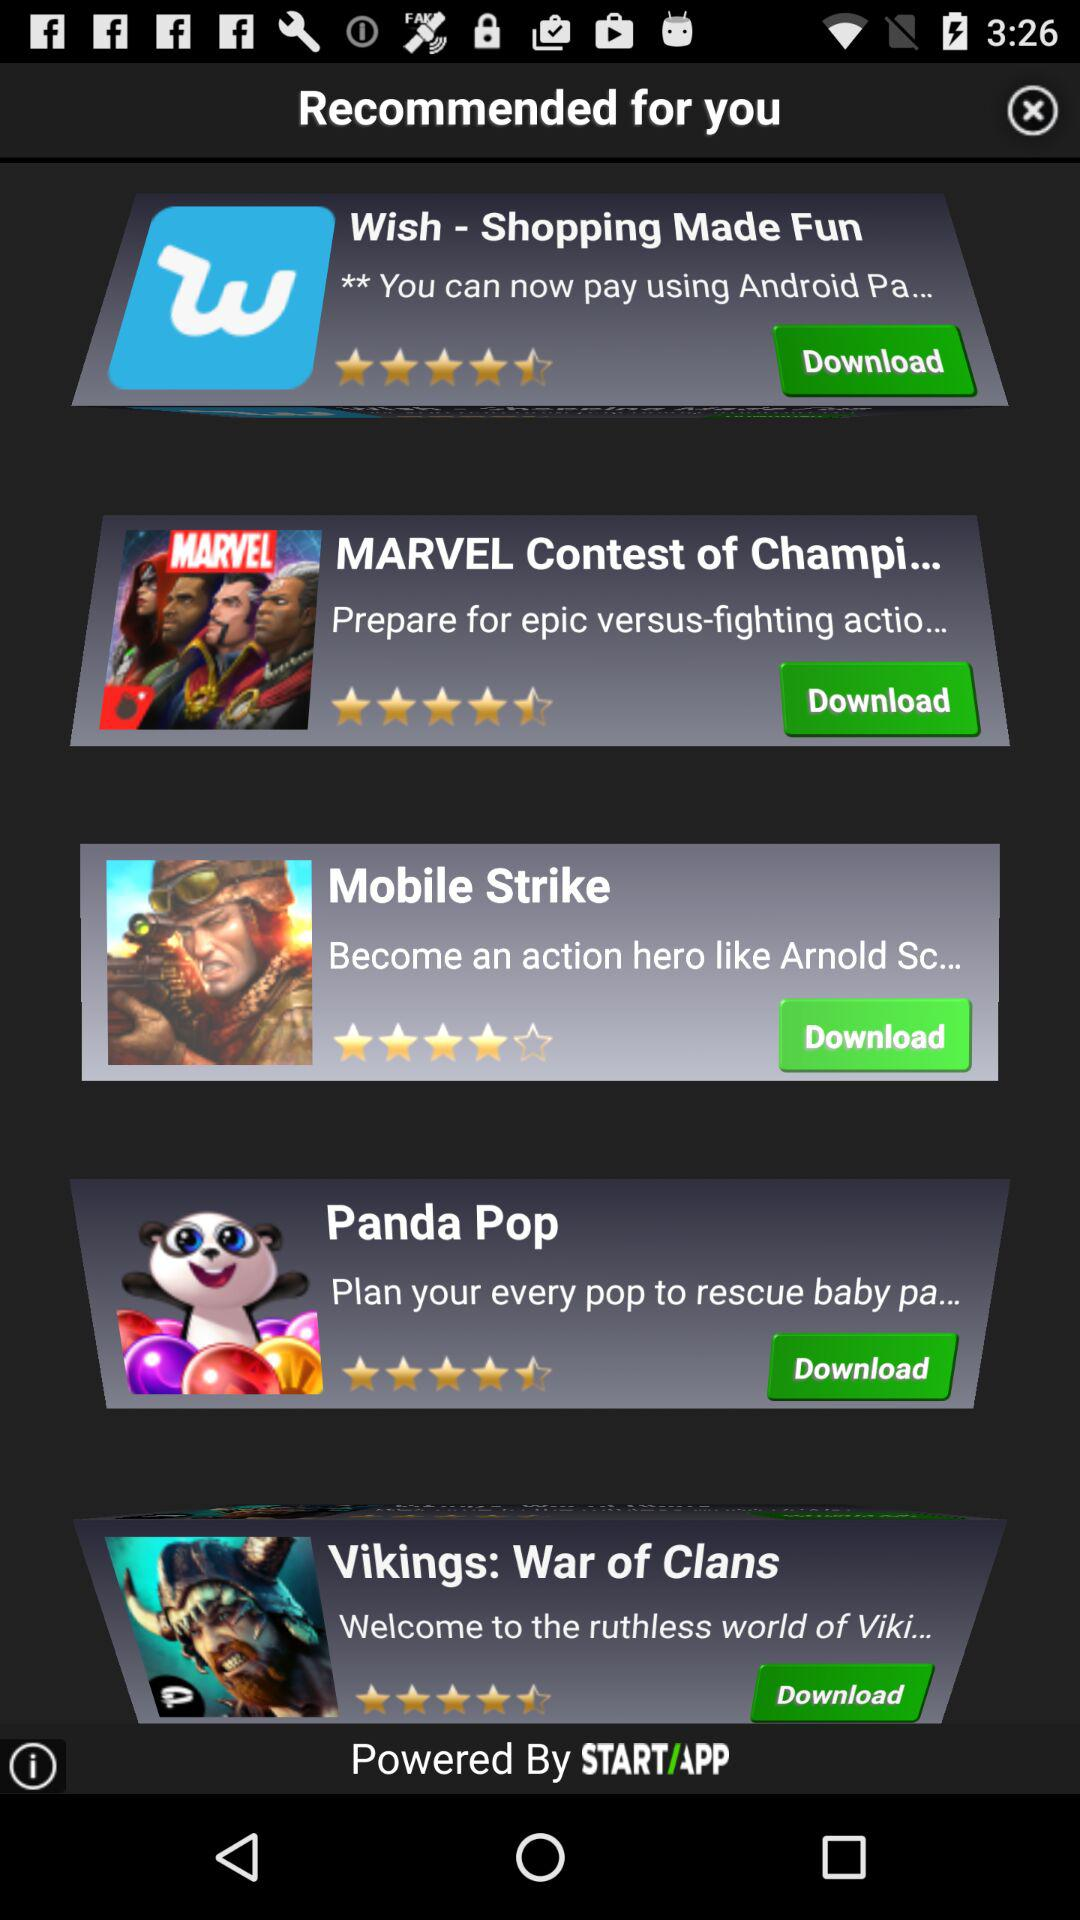What is the star rating of the application "Panda Pop"? The star rating is 4.5 stars. 